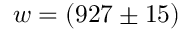<formula> <loc_0><loc_0><loc_500><loc_500>w = ( 9 2 7 \pm 1 5 )</formula> 